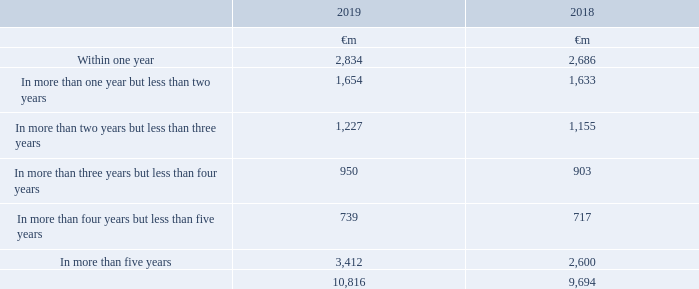Operating lease commitments
The Group has entered into commercial leases on certain properties, network infrastructure, motor vehicles and items of equipment. The leases have various terms, escalation clauses, purchase options and renewal rights, none of which are individually significant to the Group
Future minimum lease payments under non-cancellable operating leases comprise:
The total of future minimum sublease payments expected to be received under non-cancellable subleases is €1,027 million (2018: €859 million).
Which financial years' information is shown in the table? 2018, 2019. How much is the 2019 total future minimum lease payments under non-cancellable operating leases?
Answer scale should be: million. 10,816. How much is the 2018 total future minimum lease payments under non-cancellable operating leases?
Answer scale should be: million. 9,694. Between 2018 and 2019, which year had higher total future minimum lease payments under non-cancellable operating leases? 10,816>9,694
Answer: 2019. How much did future minimum lease payments due within one year change by between 2018 and 2019?
Answer scale should be: million. 2,834-2,686
Answer: 148. Between 2018 and 2019, which year had higher future minimum lease payments due within one year? 2,834>2,686
Answer: 2019. 